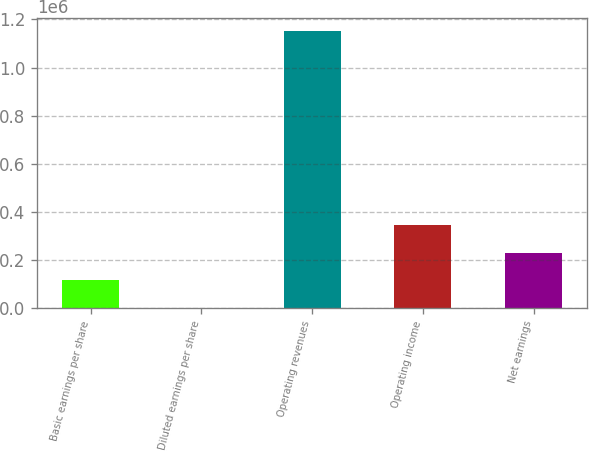<chart> <loc_0><loc_0><loc_500><loc_500><bar_chart><fcel>Basic earnings per share<fcel>Diluted earnings per share<fcel>Operating revenues<fcel>Operating income<fcel>Net earnings<nl><fcel>114986<fcel>0.67<fcel>1.14986e+06<fcel>344957<fcel>229972<nl></chart> 